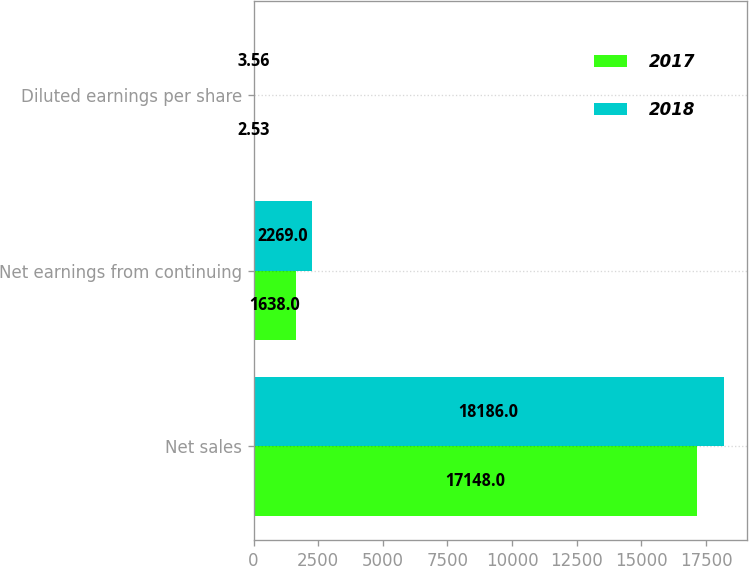<chart> <loc_0><loc_0><loc_500><loc_500><stacked_bar_chart><ecel><fcel>Net sales<fcel>Net earnings from continuing<fcel>Diluted earnings per share<nl><fcel>2017<fcel>17148<fcel>1638<fcel>2.53<nl><fcel>2018<fcel>18186<fcel>2269<fcel>3.56<nl></chart> 